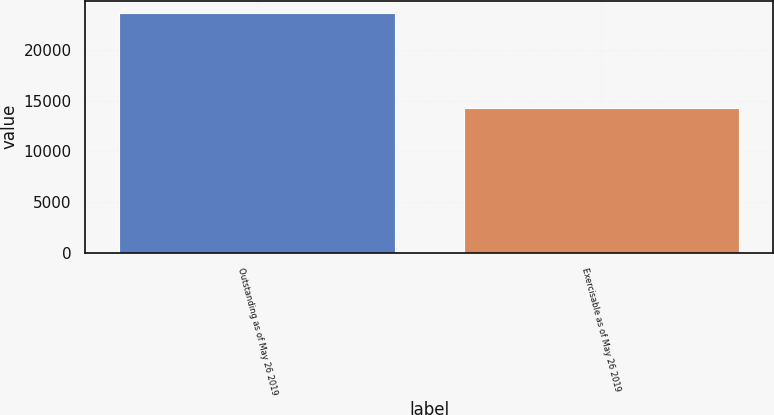Convert chart. <chart><loc_0><loc_0><loc_500><loc_500><bar_chart><fcel>Outstanding as of May 26 2019<fcel>Exercisable as of May 26 2019<nl><fcel>23653<fcel>14219<nl></chart> 